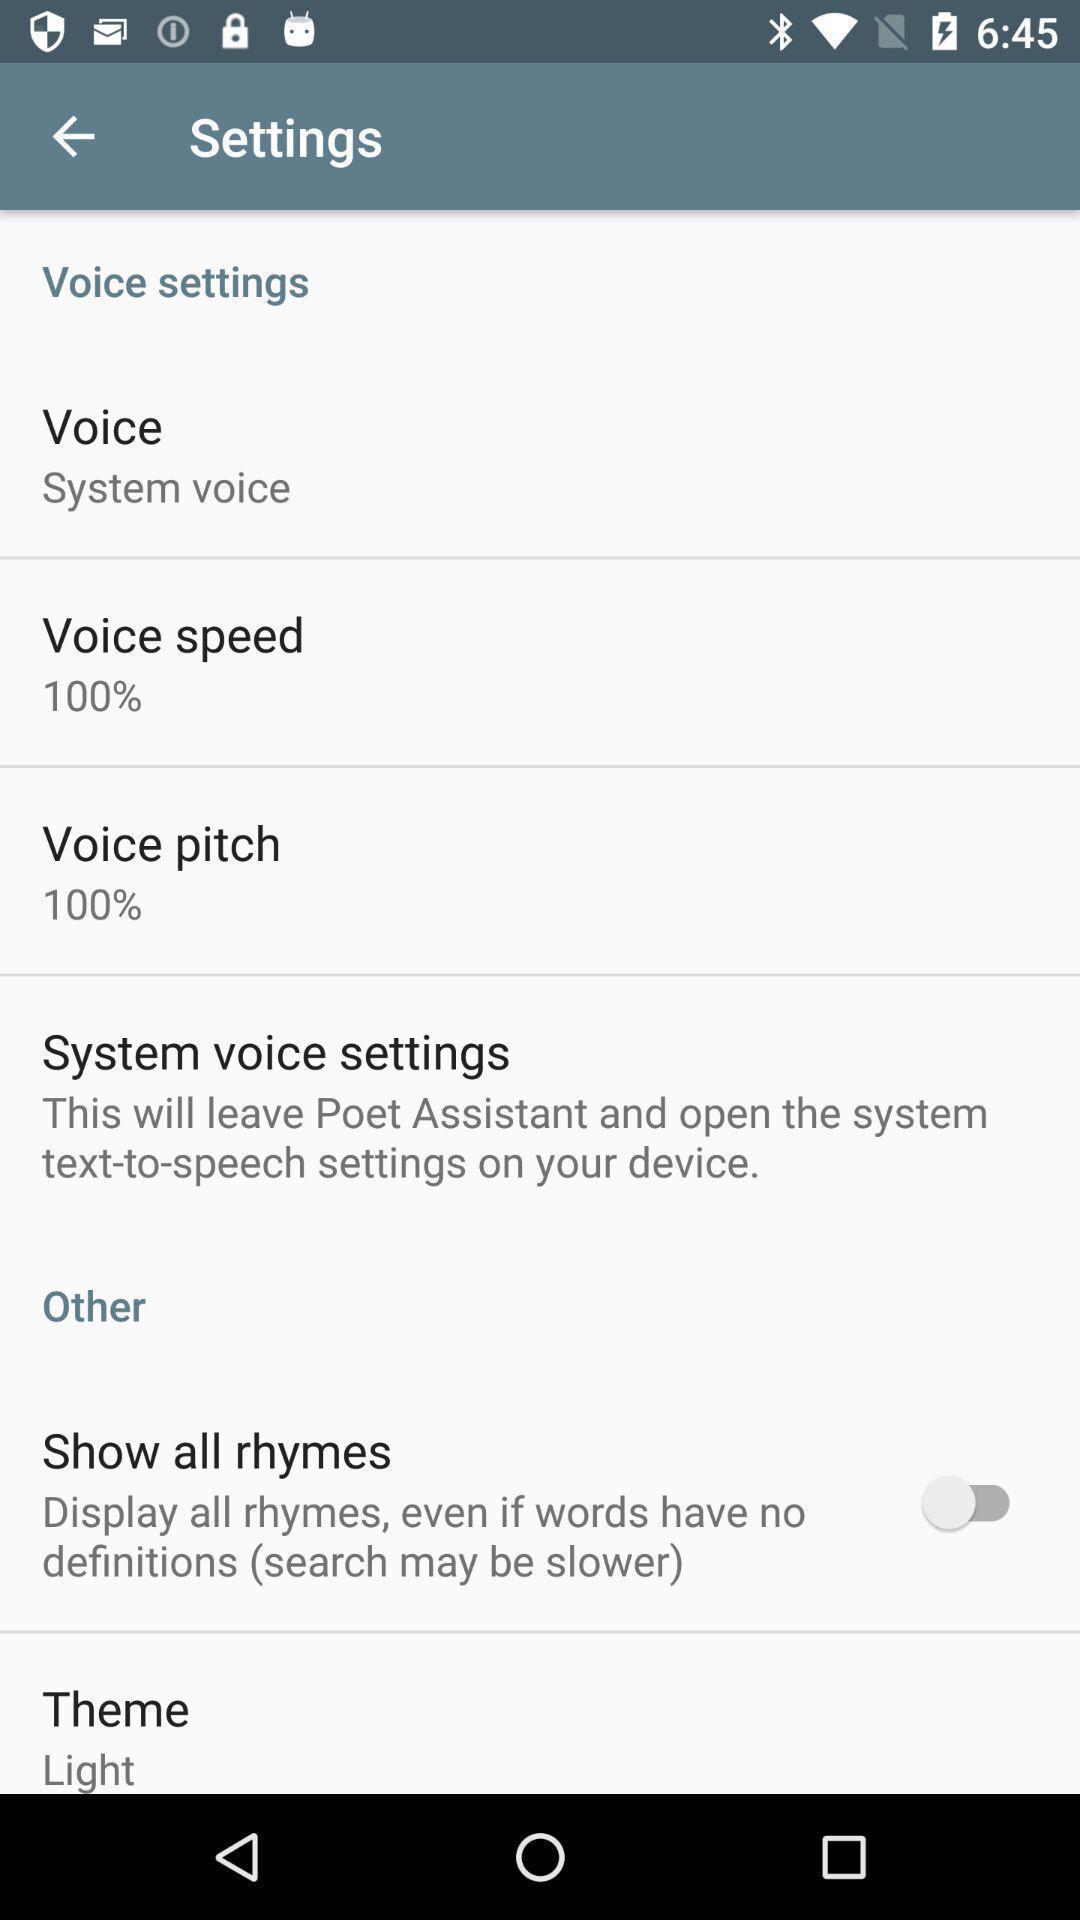Tell me about the visual elements in this screen capture. Setting page displaying the various options. 